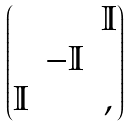<formula> <loc_0><loc_0><loc_500><loc_500>\begin{pmatrix} & & { \mathbb { I } } \\ & - { \mathbb { I } } & \\ { \mathbb { I } } & & , \end{pmatrix}</formula> 